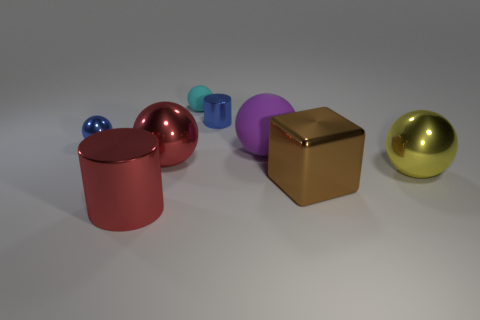What material is the blue sphere that is the same size as the cyan object?
Make the answer very short. Metal. There is a red cylinder; are there any big brown things behind it?
Your answer should be very brief. Yes. Are there an equal number of cyan rubber things that are right of the tiny blue metal cylinder and big brown metallic blocks?
Your answer should be compact. No. What is the shape of the blue shiny object that is the same size as the blue metallic ball?
Provide a succinct answer. Cylinder. What material is the large brown thing?
Offer a terse response. Metal. There is a thing that is to the left of the blue shiny cylinder and behind the small metal ball; what color is it?
Make the answer very short. Cyan. Are there the same number of large brown metal blocks that are behind the big purple matte object and tiny metal spheres in front of the red metal cylinder?
Ensure brevity in your answer.  Yes. What is the color of the block that is the same material as the blue sphere?
Your answer should be compact. Brown. Is the color of the big cylinder the same as the big shiny ball that is on the right side of the big red sphere?
Your response must be concise. No. There is a metallic cylinder in front of the metal cylinder behind the red shiny cylinder; are there any shiny cylinders that are right of it?
Your response must be concise. Yes. 